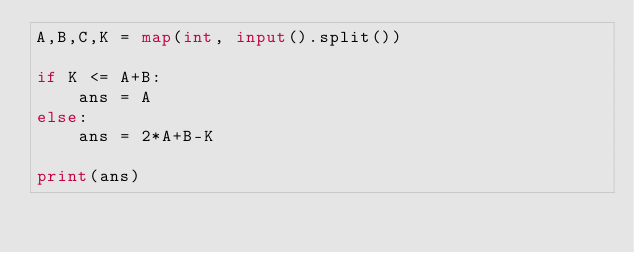<code> <loc_0><loc_0><loc_500><loc_500><_Python_>A,B,C,K = map(int, input().split())

if K <= A+B:
    ans = A
else:
    ans = 2*A+B-K

print(ans)</code> 